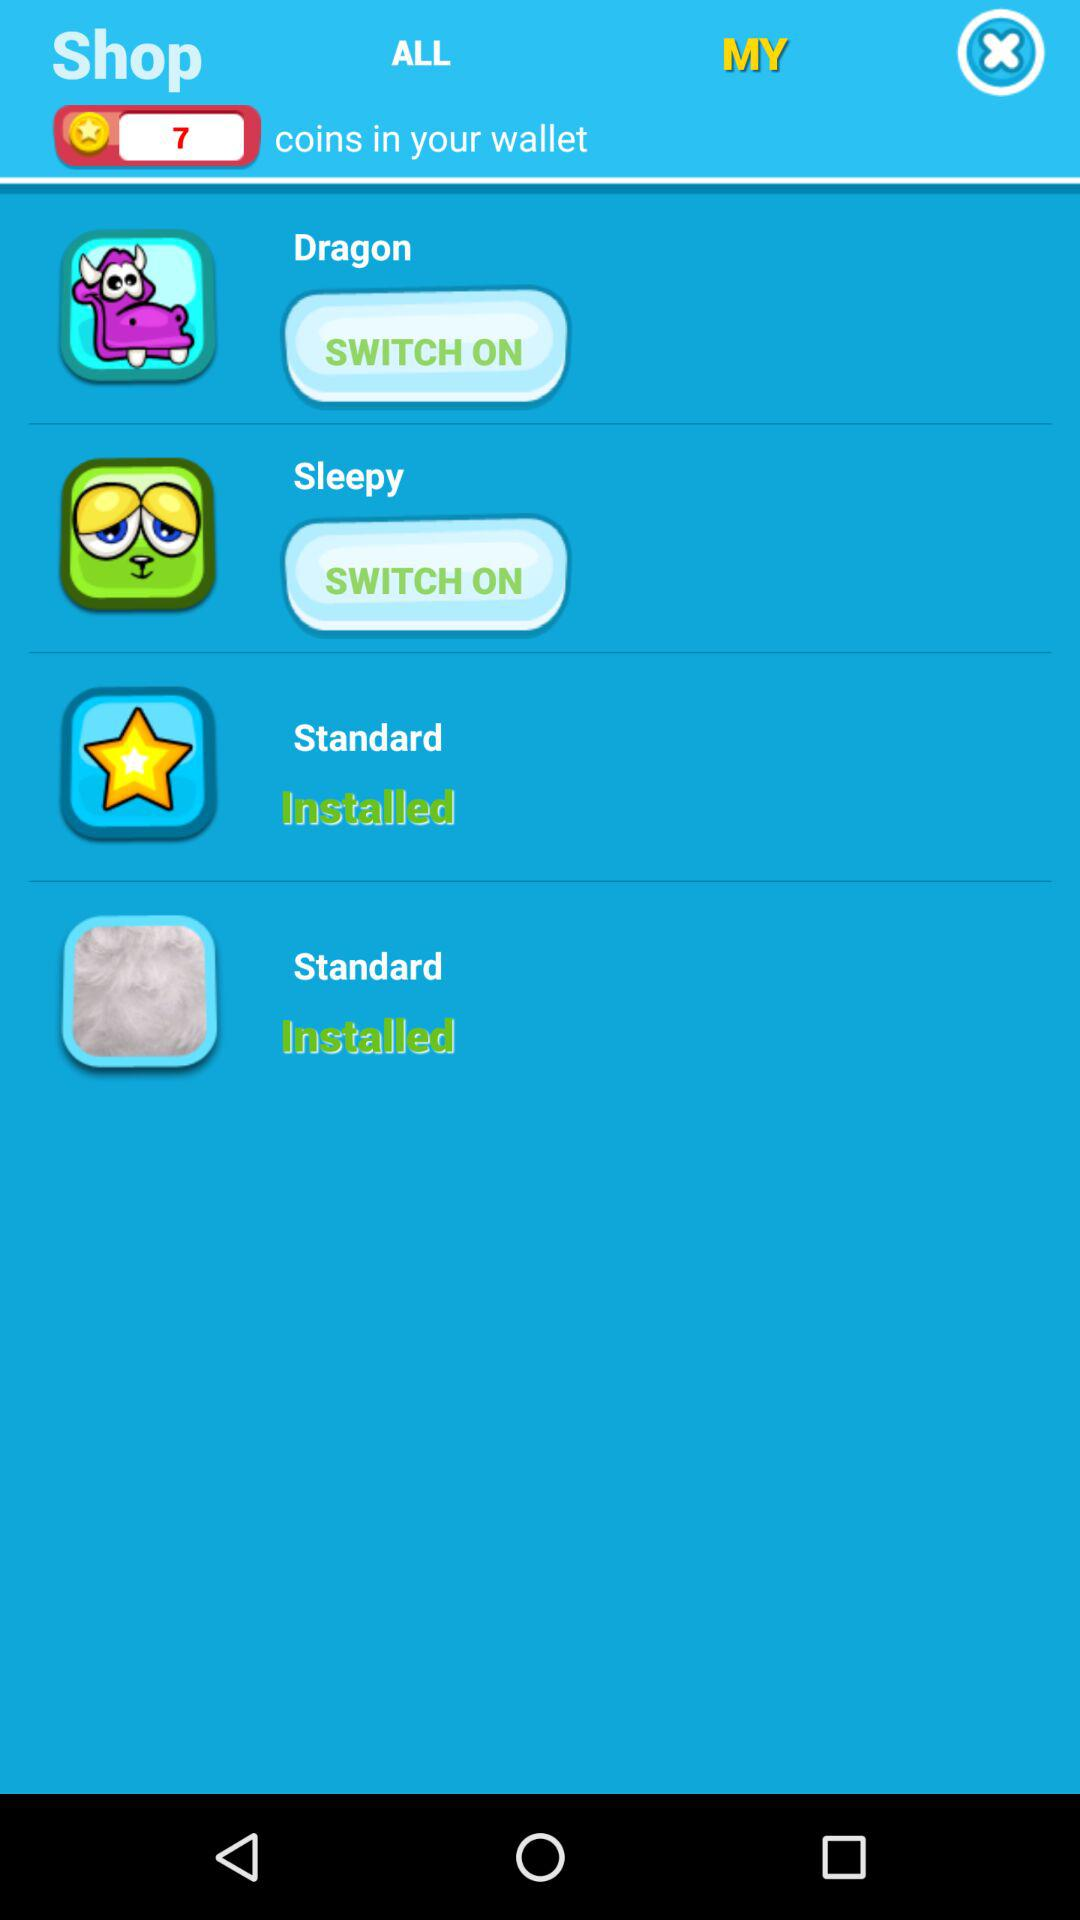How many items are in "ALL"?
When the provided information is insufficient, respond with <no answer>. <no answer> 